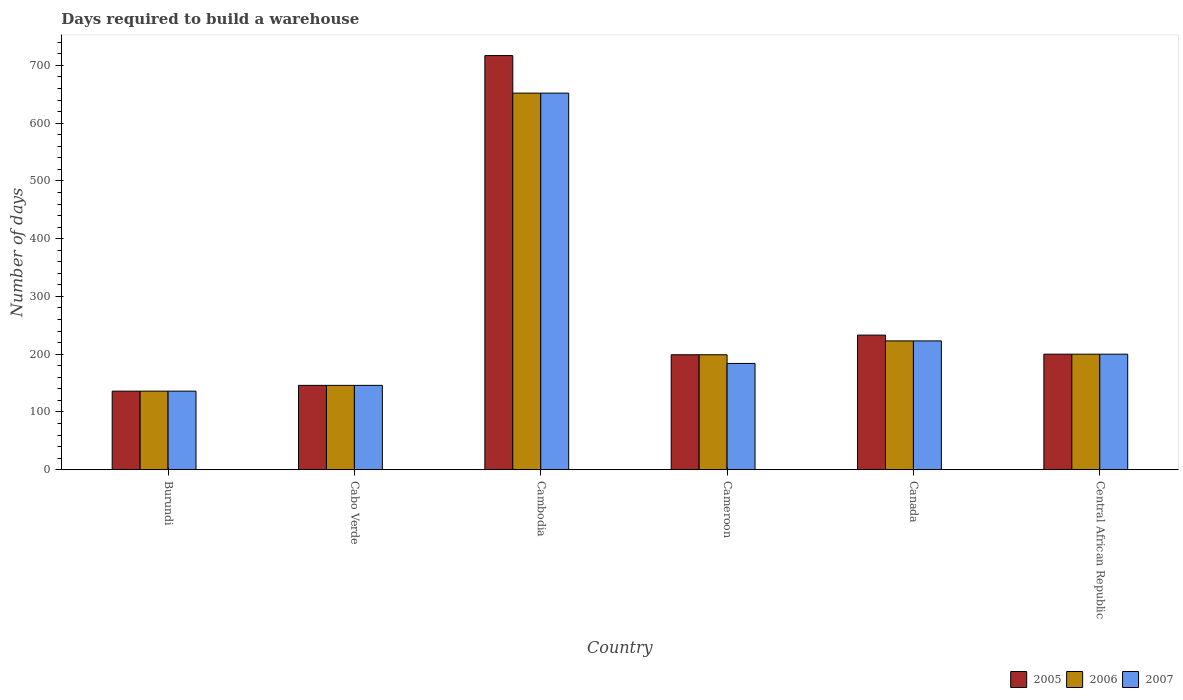How many different coloured bars are there?
Ensure brevity in your answer.  3. Are the number of bars on each tick of the X-axis equal?
Provide a succinct answer. Yes. How many bars are there on the 3rd tick from the right?
Your response must be concise. 3. What is the label of the 4th group of bars from the left?
Ensure brevity in your answer.  Cameroon. What is the days required to build a warehouse in in 2005 in Cameroon?
Your answer should be very brief. 199. Across all countries, what is the maximum days required to build a warehouse in in 2007?
Provide a succinct answer. 652. Across all countries, what is the minimum days required to build a warehouse in in 2005?
Your response must be concise. 136. In which country was the days required to build a warehouse in in 2007 maximum?
Ensure brevity in your answer.  Cambodia. In which country was the days required to build a warehouse in in 2006 minimum?
Give a very brief answer. Burundi. What is the total days required to build a warehouse in in 2006 in the graph?
Ensure brevity in your answer.  1556. What is the difference between the days required to build a warehouse in in 2005 in Cambodia and that in Central African Republic?
Provide a short and direct response. 517. What is the difference between the days required to build a warehouse in in 2005 in Burundi and the days required to build a warehouse in in 2007 in Cameroon?
Give a very brief answer. -48. What is the average days required to build a warehouse in in 2007 per country?
Make the answer very short. 256.83. What is the ratio of the days required to build a warehouse in in 2007 in Burundi to that in Central African Republic?
Offer a terse response. 0.68. Is the days required to build a warehouse in in 2005 in Burundi less than that in Central African Republic?
Make the answer very short. Yes. What is the difference between the highest and the second highest days required to build a warehouse in in 2006?
Offer a terse response. -452. What is the difference between the highest and the lowest days required to build a warehouse in in 2005?
Provide a short and direct response. 581. In how many countries, is the days required to build a warehouse in in 2005 greater than the average days required to build a warehouse in in 2005 taken over all countries?
Provide a short and direct response. 1. Is the sum of the days required to build a warehouse in in 2006 in Cambodia and Central African Republic greater than the maximum days required to build a warehouse in in 2005 across all countries?
Make the answer very short. Yes. What does the 1st bar from the right in Central African Republic represents?
Ensure brevity in your answer.  2007. How many countries are there in the graph?
Your answer should be compact. 6. Does the graph contain any zero values?
Make the answer very short. No. How many legend labels are there?
Offer a terse response. 3. What is the title of the graph?
Your answer should be very brief. Days required to build a warehouse. What is the label or title of the X-axis?
Keep it short and to the point. Country. What is the label or title of the Y-axis?
Offer a very short reply. Number of days. What is the Number of days in 2005 in Burundi?
Make the answer very short. 136. What is the Number of days of 2006 in Burundi?
Provide a short and direct response. 136. What is the Number of days of 2007 in Burundi?
Provide a succinct answer. 136. What is the Number of days of 2005 in Cabo Verde?
Provide a succinct answer. 146. What is the Number of days in 2006 in Cabo Verde?
Keep it short and to the point. 146. What is the Number of days of 2007 in Cabo Verde?
Provide a short and direct response. 146. What is the Number of days in 2005 in Cambodia?
Offer a terse response. 717. What is the Number of days of 2006 in Cambodia?
Your answer should be compact. 652. What is the Number of days of 2007 in Cambodia?
Your answer should be very brief. 652. What is the Number of days of 2005 in Cameroon?
Keep it short and to the point. 199. What is the Number of days of 2006 in Cameroon?
Give a very brief answer. 199. What is the Number of days of 2007 in Cameroon?
Offer a terse response. 184. What is the Number of days of 2005 in Canada?
Your response must be concise. 233. What is the Number of days in 2006 in Canada?
Make the answer very short. 223. What is the Number of days in 2007 in Canada?
Your answer should be compact. 223. What is the Number of days of 2005 in Central African Republic?
Make the answer very short. 200. What is the Number of days in 2006 in Central African Republic?
Your answer should be very brief. 200. What is the Number of days of 2007 in Central African Republic?
Give a very brief answer. 200. Across all countries, what is the maximum Number of days of 2005?
Your answer should be compact. 717. Across all countries, what is the maximum Number of days of 2006?
Provide a short and direct response. 652. Across all countries, what is the maximum Number of days of 2007?
Make the answer very short. 652. Across all countries, what is the minimum Number of days in 2005?
Keep it short and to the point. 136. Across all countries, what is the minimum Number of days in 2006?
Keep it short and to the point. 136. Across all countries, what is the minimum Number of days in 2007?
Your answer should be very brief. 136. What is the total Number of days of 2005 in the graph?
Make the answer very short. 1631. What is the total Number of days in 2006 in the graph?
Ensure brevity in your answer.  1556. What is the total Number of days of 2007 in the graph?
Your answer should be very brief. 1541. What is the difference between the Number of days in 2007 in Burundi and that in Cabo Verde?
Ensure brevity in your answer.  -10. What is the difference between the Number of days of 2005 in Burundi and that in Cambodia?
Keep it short and to the point. -581. What is the difference between the Number of days in 2006 in Burundi and that in Cambodia?
Provide a succinct answer. -516. What is the difference between the Number of days of 2007 in Burundi and that in Cambodia?
Offer a very short reply. -516. What is the difference between the Number of days of 2005 in Burundi and that in Cameroon?
Your answer should be very brief. -63. What is the difference between the Number of days of 2006 in Burundi and that in Cameroon?
Provide a succinct answer. -63. What is the difference between the Number of days of 2007 in Burundi and that in Cameroon?
Keep it short and to the point. -48. What is the difference between the Number of days of 2005 in Burundi and that in Canada?
Make the answer very short. -97. What is the difference between the Number of days of 2006 in Burundi and that in Canada?
Offer a terse response. -87. What is the difference between the Number of days of 2007 in Burundi and that in Canada?
Offer a very short reply. -87. What is the difference between the Number of days of 2005 in Burundi and that in Central African Republic?
Provide a succinct answer. -64. What is the difference between the Number of days of 2006 in Burundi and that in Central African Republic?
Your answer should be very brief. -64. What is the difference between the Number of days of 2007 in Burundi and that in Central African Republic?
Your answer should be very brief. -64. What is the difference between the Number of days of 2005 in Cabo Verde and that in Cambodia?
Provide a succinct answer. -571. What is the difference between the Number of days of 2006 in Cabo Verde and that in Cambodia?
Provide a short and direct response. -506. What is the difference between the Number of days in 2007 in Cabo Verde and that in Cambodia?
Offer a very short reply. -506. What is the difference between the Number of days of 2005 in Cabo Verde and that in Cameroon?
Your answer should be very brief. -53. What is the difference between the Number of days of 2006 in Cabo Verde and that in Cameroon?
Provide a short and direct response. -53. What is the difference between the Number of days of 2007 in Cabo Verde and that in Cameroon?
Your answer should be compact. -38. What is the difference between the Number of days in 2005 in Cabo Verde and that in Canada?
Provide a succinct answer. -87. What is the difference between the Number of days in 2006 in Cabo Verde and that in Canada?
Offer a very short reply. -77. What is the difference between the Number of days in 2007 in Cabo Verde and that in Canada?
Ensure brevity in your answer.  -77. What is the difference between the Number of days in 2005 in Cabo Verde and that in Central African Republic?
Your response must be concise. -54. What is the difference between the Number of days in 2006 in Cabo Verde and that in Central African Republic?
Provide a short and direct response. -54. What is the difference between the Number of days in 2007 in Cabo Verde and that in Central African Republic?
Make the answer very short. -54. What is the difference between the Number of days of 2005 in Cambodia and that in Cameroon?
Offer a very short reply. 518. What is the difference between the Number of days in 2006 in Cambodia and that in Cameroon?
Make the answer very short. 453. What is the difference between the Number of days in 2007 in Cambodia and that in Cameroon?
Provide a short and direct response. 468. What is the difference between the Number of days of 2005 in Cambodia and that in Canada?
Your response must be concise. 484. What is the difference between the Number of days in 2006 in Cambodia and that in Canada?
Your answer should be compact. 429. What is the difference between the Number of days of 2007 in Cambodia and that in Canada?
Make the answer very short. 429. What is the difference between the Number of days in 2005 in Cambodia and that in Central African Republic?
Ensure brevity in your answer.  517. What is the difference between the Number of days in 2006 in Cambodia and that in Central African Republic?
Your answer should be very brief. 452. What is the difference between the Number of days of 2007 in Cambodia and that in Central African Republic?
Offer a very short reply. 452. What is the difference between the Number of days in 2005 in Cameroon and that in Canada?
Keep it short and to the point. -34. What is the difference between the Number of days of 2006 in Cameroon and that in Canada?
Give a very brief answer. -24. What is the difference between the Number of days of 2007 in Cameroon and that in Canada?
Give a very brief answer. -39. What is the difference between the Number of days of 2005 in Cameroon and that in Central African Republic?
Ensure brevity in your answer.  -1. What is the difference between the Number of days in 2007 in Cameroon and that in Central African Republic?
Keep it short and to the point. -16. What is the difference between the Number of days in 2005 in Canada and that in Central African Republic?
Keep it short and to the point. 33. What is the difference between the Number of days of 2005 in Burundi and the Number of days of 2007 in Cabo Verde?
Give a very brief answer. -10. What is the difference between the Number of days in 2005 in Burundi and the Number of days in 2006 in Cambodia?
Provide a succinct answer. -516. What is the difference between the Number of days in 2005 in Burundi and the Number of days in 2007 in Cambodia?
Your answer should be compact. -516. What is the difference between the Number of days of 2006 in Burundi and the Number of days of 2007 in Cambodia?
Keep it short and to the point. -516. What is the difference between the Number of days of 2005 in Burundi and the Number of days of 2006 in Cameroon?
Keep it short and to the point. -63. What is the difference between the Number of days in 2005 in Burundi and the Number of days in 2007 in Cameroon?
Ensure brevity in your answer.  -48. What is the difference between the Number of days in 2006 in Burundi and the Number of days in 2007 in Cameroon?
Ensure brevity in your answer.  -48. What is the difference between the Number of days in 2005 in Burundi and the Number of days in 2006 in Canada?
Keep it short and to the point. -87. What is the difference between the Number of days in 2005 in Burundi and the Number of days in 2007 in Canada?
Offer a terse response. -87. What is the difference between the Number of days of 2006 in Burundi and the Number of days of 2007 in Canada?
Keep it short and to the point. -87. What is the difference between the Number of days of 2005 in Burundi and the Number of days of 2006 in Central African Republic?
Keep it short and to the point. -64. What is the difference between the Number of days of 2005 in Burundi and the Number of days of 2007 in Central African Republic?
Ensure brevity in your answer.  -64. What is the difference between the Number of days of 2006 in Burundi and the Number of days of 2007 in Central African Republic?
Offer a very short reply. -64. What is the difference between the Number of days in 2005 in Cabo Verde and the Number of days in 2006 in Cambodia?
Give a very brief answer. -506. What is the difference between the Number of days in 2005 in Cabo Verde and the Number of days in 2007 in Cambodia?
Provide a succinct answer. -506. What is the difference between the Number of days in 2006 in Cabo Verde and the Number of days in 2007 in Cambodia?
Keep it short and to the point. -506. What is the difference between the Number of days of 2005 in Cabo Verde and the Number of days of 2006 in Cameroon?
Ensure brevity in your answer.  -53. What is the difference between the Number of days of 2005 in Cabo Verde and the Number of days of 2007 in Cameroon?
Your answer should be compact. -38. What is the difference between the Number of days in 2006 in Cabo Verde and the Number of days in 2007 in Cameroon?
Provide a short and direct response. -38. What is the difference between the Number of days of 2005 in Cabo Verde and the Number of days of 2006 in Canada?
Your answer should be very brief. -77. What is the difference between the Number of days in 2005 in Cabo Verde and the Number of days in 2007 in Canada?
Make the answer very short. -77. What is the difference between the Number of days of 2006 in Cabo Verde and the Number of days of 2007 in Canada?
Give a very brief answer. -77. What is the difference between the Number of days in 2005 in Cabo Verde and the Number of days in 2006 in Central African Republic?
Provide a short and direct response. -54. What is the difference between the Number of days in 2005 in Cabo Verde and the Number of days in 2007 in Central African Republic?
Offer a very short reply. -54. What is the difference between the Number of days in 2006 in Cabo Verde and the Number of days in 2007 in Central African Republic?
Provide a short and direct response. -54. What is the difference between the Number of days in 2005 in Cambodia and the Number of days in 2006 in Cameroon?
Give a very brief answer. 518. What is the difference between the Number of days of 2005 in Cambodia and the Number of days of 2007 in Cameroon?
Provide a succinct answer. 533. What is the difference between the Number of days of 2006 in Cambodia and the Number of days of 2007 in Cameroon?
Provide a succinct answer. 468. What is the difference between the Number of days of 2005 in Cambodia and the Number of days of 2006 in Canada?
Keep it short and to the point. 494. What is the difference between the Number of days in 2005 in Cambodia and the Number of days in 2007 in Canada?
Provide a short and direct response. 494. What is the difference between the Number of days of 2006 in Cambodia and the Number of days of 2007 in Canada?
Make the answer very short. 429. What is the difference between the Number of days of 2005 in Cambodia and the Number of days of 2006 in Central African Republic?
Your response must be concise. 517. What is the difference between the Number of days in 2005 in Cambodia and the Number of days in 2007 in Central African Republic?
Make the answer very short. 517. What is the difference between the Number of days of 2006 in Cambodia and the Number of days of 2007 in Central African Republic?
Your response must be concise. 452. What is the difference between the Number of days of 2005 in Cameroon and the Number of days of 2006 in Canada?
Offer a very short reply. -24. What is the difference between the Number of days of 2005 in Cameroon and the Number of days of 2007 in Canada?
Your answer should be very brief. -24. What is the difference between the Number of days of 2005 in Cameroon and the Number of days of 2007 in Central African Republic?
Your response must be concise. -1. What is the difference between the Number of days of 2005 in Canada and the Number of days of 2007 in Central African Republic?
Your answer should be very brief. 33. What is the average Number of days in 2005 per country?
Your answer should be compact. 271.83. What is the average Number of days in 2006 per country?
Offer a very short reply. 259.33. What is the average Number of days of 2007 per country?
Keep it short and to the point. 256.83. What is the difference between the Number of days in 2005 and Number of days in 2006 in Burundi?
Offer a very short reply. 0. What is the difference between the Number of days in 2005 and Number of days in 2007 in Burundi?
Keep it short and to the point. 0. What is the difference between the Number of days in 2006 and Number of days in 2007 in Burundi?
Make the answer very short. 0. What is the difference between the Number of days in 2006 and Number of days in 2007 in Cabo Verde?
Your answer should be very brief. 0. What is the difference between the Number of days in 2005 and Number of days in 2007 in Cambodia?
Keep it short and to the point. 65. What is the difference between the Number of days in 2005 and Number of days in 2007 in Cameroon?
Ensure brevity in your answer.  15. What is the difference between the Number of days in 2005 and Number of days in 2006 in Central African Republic?
Provide a short and direct response. 0. What is the ratio of the Number of days of 2005 in Burundi to that in Cabo Verde?
Your answer should be very brief. 0.93. What is the ratio of the Number of days of 2006 in Burundi to that in Cabo Verde?
Provide a short and direct response. 0.93. What is the ratio of the Number of days in 2007 in Burundi to that in Cabo Verde?
Ensure brevity in your answer.  0.93. What is the ratio of the Number of days of 2005 in Burundi to that in Cambodia?
Provide a short and direct response. 0.19. What is the ratio of the Number of days of 2006 in Burundi to that in Cambodia?
Your response must be concise. 0.21. What is the ratio of the Number of days in 2007 in Burundi to that in Cambodia?
Ensure brevity in your answer.  0.21. What is the ratio of the Number of days in 2005 in Burundi to that in Cameroon?
Provide a short and direct response. 0.68. What is the ratio of the Number of days in 2006 in Burundi to that in Cameroon?
Provide a short and direct response. 0.68. What is the ratio of the Number of days of 2007 in Burundi to that in Cameroon?
Ensure brevity in your answer.  0.74. What is the ratio of the Number of days in 2005 in Burundi to that in Canada?
Give a very brief answer. 0.58. What is the ratio of the Number of days in 2006 in Burundi to that in Canada?
Your answer should be compact. 0.61. What is the ratio of the Number of days of 2007 in Burundi to that in Canada?
Ensure brevity in your answer.  0.61. What is the ratio of the Number of days of 2005 in Burundi to that in Central African Republic?
Provide a succinct answer. 0.68. What is the ratio of the Number of days of 2006 in Burundi to that in Central African Republic?
Keep it short and to the point. 0.68. What is the ratio of the Number of days of 2007 in Burundi to that in Central African Republic?
Offer a very short reply. 0.68. What is the ratio of the Number of days of 2005 in Cabo Verde to that in Cambodia?
Your response must be concise. 0.2. What is the ratio of the Number of days in 2006 in Cabo Verde to that in Cambodia?
Offer a terse response. 0.22. What is the ratio of the Number of days of 2007 in Cabo Verde to that in Cambodia?
Offer a very short reply. 0.22. What is the ratio of the Number of days in 2005 in Cabo Verde to that in Cameroon?
Offer a terse response. 0.73. What is the ratio of the Number of days of 2006 in Cabo Verde to that in Cameroon?
Offer a terse response. 0.73. What is the ratio of the Number of days of 2007 in Cabo Verde to that in Cameroon?
Offer a very short reply. 0.79. What is the ratio of the Number of days of 2005 in Cabo Verde to that in Canada?
Offer a terse response. 0.63. What is the ratio of the Number of days of 2006 in Cabo Verde to that in Canada?
Your answer should be very brief. 0.65. What is the ratio of the Number of days of 2007 in Cabo Verde to that in Canada?
Your response must be concise. 0.65. What is the ratio of the Number of days in 2005 in Cabo Verde to that in Central African Republic?
Your answer should be compact. 0.73. What is the ratio of the Number of days in 2006 in Cabo Verde to that in Central African Republic?
Give a very brief answer. 0.73. What is the ratio of the Number of days in 2007 in Cabo Verde to that in Central African Republic?
Provide a short and direct response. 0.73. What is the ratio of the Number of days of 2005 in Cambodia to that in Cameroon?
Your answer should be very brief. 3.6. What is the ratio of the Number of days of 2006 in Cambodia to that in Cameroon?
Keep it short and to the point. 3.28. What is the ratio of the Number of days of 2007 in Cambodia to that in Cameroon?
Your answer should be very brief. 3.54. What is the ratio of the Number of days of 2005 in Cambodia to that in Canada?
Give a very brief answer. 3.08. What is the ratio of the Number of days in 2006 in Cambodia to that in Canada?
Make the answer very short. 2.92. What is the ratio of the Number of days in 2007 in Cambodia to that in Canada?
Offer a very short reply. 2.92. What is the ratio of the Number of days in 2005 in Cambodia to that in Central African Republic?
Ensure brevity in your answer.  3.58. What is the ratio of the Number of days in 2006 in Cambodia to that in Central African Republic?
Keep it short and to the point. 3.26. What is the ratio of the Number of days of 2007 in Cambodia to that in Central African Republic?
Ensure brevity in your answer.  3.26. What is the ratio of the Number of days of 2005 in Cameroon to that in Canada?
Your response must be concise. 0.85. What is the ratio of the Number of days in 2006 in Cameroon to that in Canada?
Keep it short and to the point. 0.89. What is the ratio of the Number of days in 2007 in Cameroon to that in Canada?
Your response must be concise. 0.83. What is the ratio of the Number of days of 2005 in Canada to that in Central African Republic?
Give a very brief answer. 1.17. What is the ratio of the Number of days of 2006 in Canada to that in Central African Republic?
Make the answer very short. 1.11. What is the ratio of the Number of days of 2007 in Canada to that in Central African Republic?
Offer a very short reply. 1.11. What is the difference between the highest and the second highest Number of days in 2005?
Provide a succinct answer. 484. What is the difference between the highest and the second highest Number of days of 2006?
Offer a very short reply. 429. What is the difference between the highest and the second highest Number of days of 2007?
Provide a short and direct response. 429. What is the difference between the highest and the lowest Number of days of 2005?
Ensure brevity in your answer.  581. What is the difference between the highest and the lowest Number of days of 2006?
Keep it short and to the point. 516. What is the difference between the highest and the lowest Number of days of 2007?
Offer a very short reply. 516. 